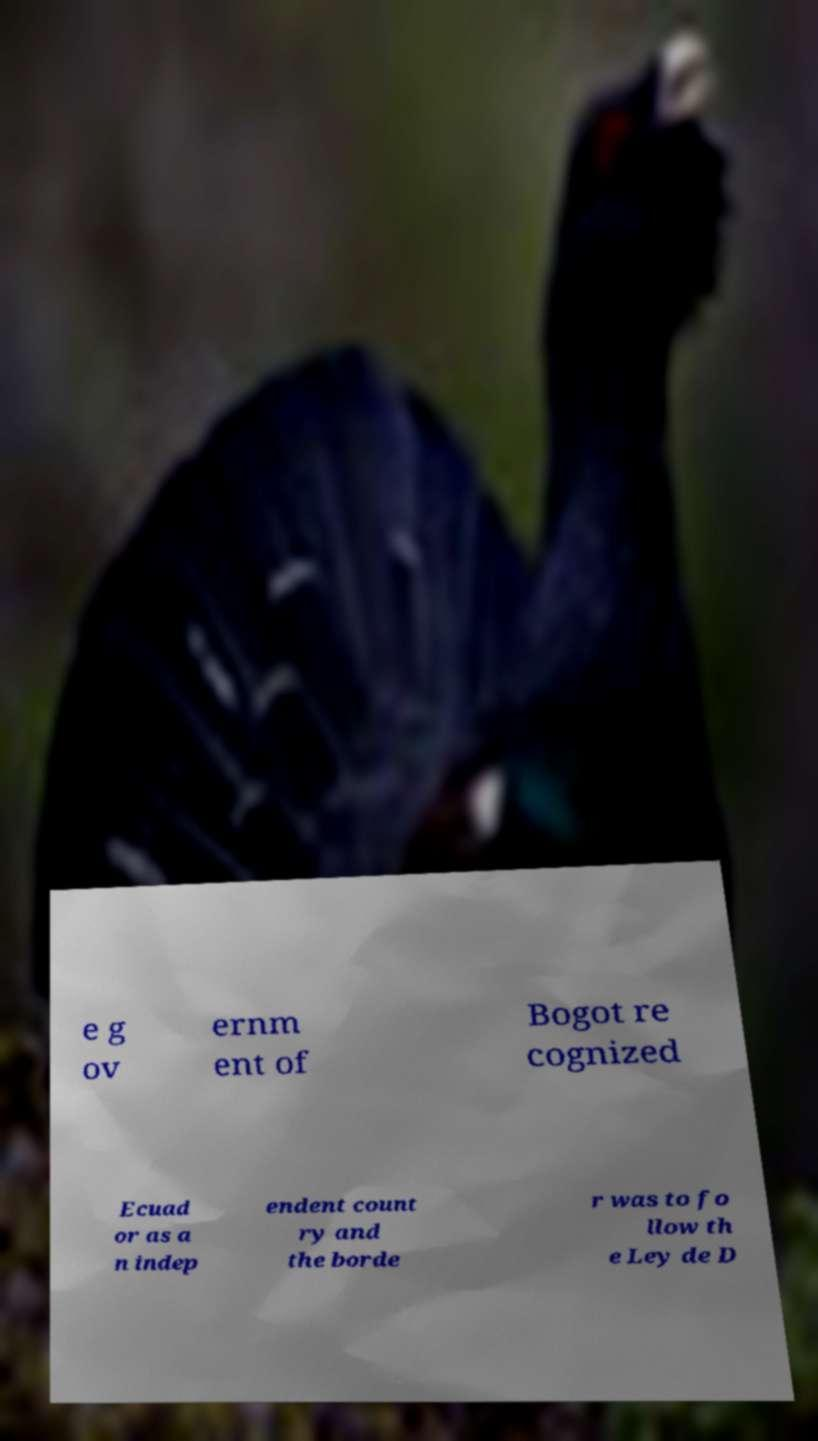Can you read and provide the text displayed in the image?This photo seems to have some interesting text. Can you extract and type it out for me? e g ov ernm ent of Bogot re cognized Ecuad or as a n indep endent count ry and the borde r was to fo llow th e Ley de D 